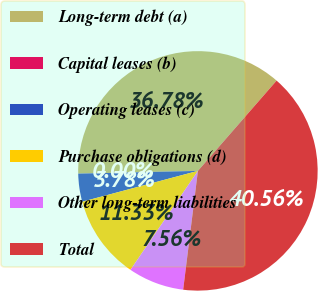Convert chart to OTSL. <chart><loc_0><loc_0><loc_500><loc_500><pie_chart><fcel>Long-term debt (a)<fcel>Capital leases (b)<fcel>Operating leases (c)<fcel>Purchase obligations (d)<fcel>Other long-term liabilities<fcel>Total<nl><fcel>36.78%<fcel>0.0%<fcel>3.78%<fcel>11.33%<fcel>7.56%<fcel>40.56%<nl></chart> 